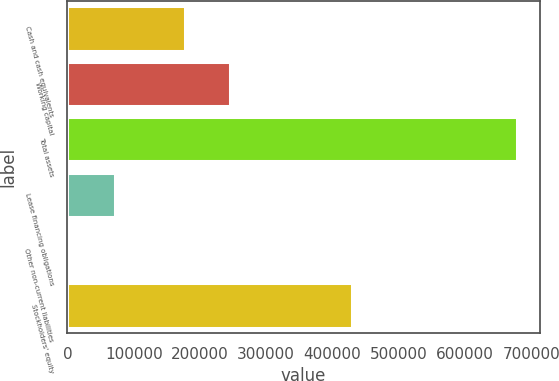Convert chart to OTSL. <chart><loc_0><loc_0><loc_500><loc_500><bar_chart><fcel>Cash and cash equivalents<fcel>Working capital<fcel>Total assets<fcel>Lease financing obligations<fcel>Other non-current liabilities<fcel>Stockholders' equity<nl><fcel>177439<fcel>244876<fcel>678998<fcel>72065.9<fcel>4629<fcel>429812<nl></chart> 